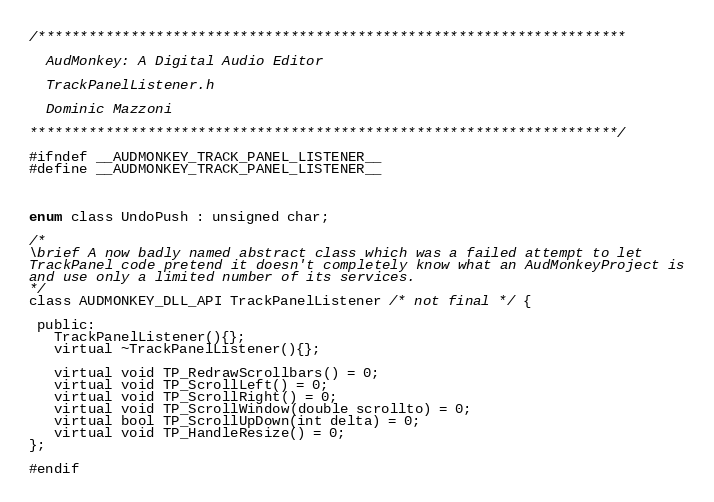Convert code to text. <code><loc_0><loc_0><loc_500><loc_500><_C_>/**********************************************************************

  AudMonkey: A Digital Audio Editor

  TrackPanelListener.h

  Dominic Mazzoni

**********************************************************************/

#ifndef __AUDMONKEY_TRACK_PANEL_LISTENER__
#define __AUDMONKEY_TRACK_PANEL_LISTENER__



enum class UndoPush : unsigned char;

/*
\brief A now badly named abstract class which was a failed attempt to let
TrackPanel code pretend it doesn't completely know what an AudMonkeyProject is
and use only a limited number of its services.
*/
class AUDMONKEY_DLL_API TrackPanelListener /* not final */ {

 public:
   TrackPanelListener(){};
   virtual ~TrackPanelListener(){};

   virtual void TP_RedrawScrollbars() = 0;
   virtual void TP_ScrollLeft() = 0;
   virtual void TP_ScrollRight() = 0;
   virtual void TP_ScrollWindow(double scrollto) = 0;
   virtual bool TP_ScrollUpDown(int delta) = 0;
   virtual void TP_HandleResize() = 0;
};

#endif
</code> 